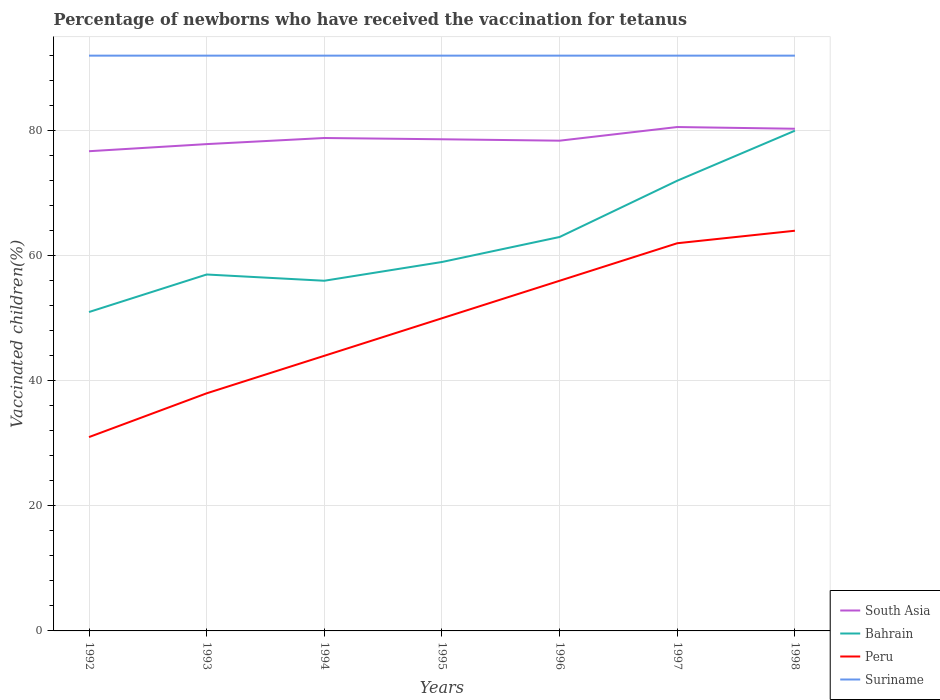Is the number of lines equal to the number of legend labels?
Offer a terse response. Yes. Across all years, what is the maximum percentage of vaccinated children in Suriname?
Provide a short and direct response. 92. In which year was the percentage of vaccinated children in Peru maximum?
Your answer should be compact. 1992. What is the difference between the highest and the second highest percentage of vaccinated children in South Asia?
Offer a terse response. 3.87. What is the difference between two consecutive major ticks on the Y-axis?
Your response must be concise. 20. Does the graph contain any zero values?
Your answer should be compact. No. Where does the legend appear in the graph?
Give a very brief answer. Bottom right. How many legend labels are there?
Ensure brevity in your answer.  4. How are the legend labels stacked?
Your response must be concise. Vertical. What is the title of the graph?
Offer a terse response. Percentage of newborns who have received the vaccination for tetanus. What is the label or title of the X-axis?
Ensure brevity in your answer.  Years. What is the label or title of the Y-axis?
Give a very brief answer. Vaccinated children(%). What is the Vaccinated children(%) of South Asia in 1992?
Provide a short and direct response. 76.72. What is the Vaccinated children(%) of Bahrain in 1992?
Make the answer very short. 51. What is the Vaccinated children(%) of Peru in 1992?
Your answer should be very brief. 31. What is the Vaccinated children(%) of Suriname in 1992?
Offer a terse response. 92. What is the Vaccinated children(%) in South Asia in 1993?
Provide a succinct answer. 77.85. What is the Vaccinated children(%) of Suriname in 1993?
Your answer should be compact. 92. What is the Vaccinated children(%) in South Asia in 1994?
Provide a short and direct response. 78.83. What is the Vaccinated children(%) of Peru in 1994?
Offer a terse response. 44. What is the Vaccinated children(%) of Suriname in 1994?
Make the answer very short. 92. What is the Vaccinated children(%) of South Asia in 1995?
Your answer should be compact. 78.63. What is the Vaccinated children(%) of Suriname in 1995?
Your answer should be very brief. 92. What is the Vaccinated children(%) in South Asia in 1996?
Ensure brevity in your answer.  78.4. What is the Vaccinated children(%) in Bahrain in 1996?
Your answer should be very brief. 63. What is the Vaccinated children(%) in Peru in 1996?
Provide a succinct answer. 56. What is the Vaccinated children(%) of Suriname in 1996?
Offer a very short reply. 92. What is the Vaccinated children(%) of South Asia in 1997?
Offer a terse response. 80.58. What is the Vaccinated children(%) of Suriname in 1997?
Make the answer very short. 92. What is the Vaccinated children(%) of South Asia in 1998?
Your answer should be compact. 80.31. What is the Vaccinated children(%) in Bahrain in 1998?
Keep it short and to the point. 80. What is the Vaccinated children(%) of Peru in 1998?
Give a very brief answer. 64. What is the Vaccinated children(%) of Suriname in 1998?
Provide a short and direct response. 92. Across all years, what is the maximum Vaccinated children(%) in South Asia?
Provide a succinct answer. 80.58. Across all years, what is the maximum Vaccinated children(%) in Suriname?
Offer a terse response. 92. Across all years, what is the minimum Vaccinated children(%) of South Asia?
Give a very brief answer. 76.72. Across all years, what is the minimum Vaccinated children(%) of Peru?
Keep it short and to the point. 31. Across all years, what is the minimum Vaccinated children(%) in Suriname?
Your response must be concise. 92. What is the total Vaccinated children(%) in South Asia in the graph?
Provide a short and direct response. 551.32. What is the total Vaccinated children(%) in Bahrain in the graph?
Ensure brevity in your answer.  438. What is the total Vaccinated children(%) of Peru in the graph?
Keep it short and to the point. 345. What is the total Vaccinated children(%) in Suriname in the graph?
Your response must be concise. 644. What is the difference between the Vaccinated children(%) of South Asia in 1992 and that in 1993?
Give a very brief answer. -1.14. What is the difference between the Vaccinated children(%) of Peru in 1992 and that in 1993?
Your answer should be compact. -7. What is the difference between the Vaccinated children(%) of South Asia in 1992 and that in 1994?
Your answer should be very brief. -2.11. What is the difference between the Vaccinated children(%) of Bahrain in 1992 and that in 1994?
Keep it short and to the point. -5. What is the difference between the Vaccinated children(%) in South Asia in 1992 and that in 1995?
Your answer should be very brief. -1.91. What is the difference between the Vaccinated children(%) in Bahrain in 1992 and that in 1995?
Make the answer very short. -8. What is the difference between the Vaccinated children(%) in Peru in 1992 and that in 1995?
Offer a terse response. -19. What is the difference between the Vaccinated children(%) of South Asia in 1992 and that in 1996?
Offer a very short reply. -1.69. What is the difference between the Vaccinated children(%) in Bahrain in 1992 and that in 1996?
Offer a terse response. -12. What is the difference between the Vaccinated children(%) in Peru in 1992 and that in 1996?
Your response must be concise. -25. What is the difference between the Vaccinated children(%) of South Asia in 1992 and that in 1997?
Keep it short and to the point. -3.87. What is the difference between the Vaccinated children(%) in Peru in 1992 and that in 1997?
Make the answer very short. -31. What is the difference between the Vaccinated children(%) of Suriname in 1992 and that in 1997?
Offer a very short reply. 0. What is the difference between the Vaccinated children(%) in South Asia in 1992 and that in 1998?
Offer a terse response. -3.59. What is the difference between the Vaccinated children(%) in Bahrain in 1992 and that in 1998?
Provide a succinct answer. -29. What is the difference between the Vaccinated children(%) in Peru in 1992 and that in 1998?
Ensure brevity in your answer.  -33. What is the difference between the Vaccinated children(%) in South Asia in 1993 and that in 1994?
Provide a short and direct response. -0.98. What is the difference between the Vaccinated children(%) in Bahrain in 1993 and that in 1994?
Offer a very short reply. 1. What is the difference between the Vaccinated children(%) in South Asia in 1993 and that in 1995?
Give a very brief answer. -0.77. What is the difference between the Vaccinated children(%) of Peru in 1993 and that in 1995?
Your response must be concise. -12. What is the difference between the Vaccinated children(%) in Suriname in 1993 and that in 1995?
Offer a terse response. 0. What is the difference between the Vaccinated children(%) of South Asia in 1993 and that in 1996?
Your response must be concise. -0.55. What is the difference between the Vaccinated children(%) of Bahrain in 1993 and that in 1996?
Make the answer very short. -6. What is the difference between the Vaccinated children(%) of South Asia in 1993 and that in 1997?
Make the answer very short. -2.73. What is the difference between the Vaccinated children(%) of Bahrain in 1993 and that in 1997?
Your answer should be compact. -15. What is the difference between the Vaccinated children(%) in Peru in 1993 and that in 1997?
Your answer should be compact. -24. What is the difference between the Vaccinated children(%) of Suriname in 1993 and that in 1997?
Give a very brief answer. 0. What is the difference between the Vaccinated children(%) in South Asia in 1993 and that in 1998?
Make the answer very short. -2.46. What is the difference between the Vaccinated children(%) in Peru in 1993 and that in 1998?
Give a very brief answer. -26. What is the difference between the Vaccinated children(%) in South Asia in 1994 and that in 1995?
Ensure brevity in your answer.  0.2. What is the difference between the Vaccinated children(%) of Peru in 1994 and that in 1995?
Provide a succinct answer. -6. What is the difference between the Vaccinated children(%) in South Asia in 1994 and that in 1996?
Your answer should be compact. 0.43. What is the difference between the Vaccinated children(%) of Bahrain in 1994 and that in 1996?
Your answer should be very brief. -7. What is the difference between the Vaccinated children(%) in Suriname in 1994 and that in 1996?
Your response must be concise. 0. What is the difference between the Vaccinated children(%) of South Asia in 1994 and that in 1997?
Offer a very short reply. -1.76. What is the difference between the Vaccinated children(%) in Suriname in 1994 and that in 1997?
Provide a short and direct response. 0. What is the difference between the Vaccinated children(%) of South Asia in 1994 and that in 1998?
Provide a short and direct response. -1.48. What is the difference between the Vaccinated children(%) in Bahrain in 1994 and that in 1998?
Provide a short and direct response. -24. What is the difference between the Vaccinated children(%) of South Asia in 1995 and that in 1996?
Your answer should be very brief. 0.22. What is the difference between the Vaccinated children(%) of Bahrain in 1995 and that in 1996?
Your answer should be compact. -4. What is the difference between the Vaccinated children(%) in Peru in 1995 and that in 1996?
Offer a terse response. -6. What is the difference between the Vaccinated children(%) in Suriname in 1995 and that in 1996?
Offer a very short reply. 0. What is the difference between the Vaccinated children(%) of South Asia in 1995 and that in 1997?
Your response must be concise. -1.96. What is the difference between the Vaccinated children(%) in Bahrain in 1995 and that in 1997?
Offer a very short reply. -13. What is the difference between the Vaccinated children(%) in South Asia in 1995 and that in 1998?
Give a very brief answer. -1.68. What is the difference between the Vaccinated children(%) of South Asia in 1996 and that in 1997?
Make the answer very short. -2.18. What is the difference between the Vaccinated children(%) of Bahrain in 1996 and that in 1997?
Give a very brief answer. -9. What is the difference between the Vaccinated children(%) of Peru in 1996 and that in 1997?
Ensure brevity in your answer.  -6. What is the difference between the Vaccinated children(%) in South Asia in 1996 and that in 1998?
Provide a succinct answer. -1.91. What is the difference between the Vaccinated children(%) of Bahrain in 1996 and that in 1998?
Provide a short and direct response. -17. What is the difference between the Vaccinated children(%) in Peru in 1996 and that in 1998?
Your response must be concise. -8. What is the difference between the Vaccinated children(%) in Suriname in 1996 and that in 1998?
Your response must be concise. 0. What is the difference between the Vaccinated children(%) of South Asia in 1997 and that in 1998?
Offer a terse response. 0.28. What is the difference between the Vaccinated children(%) of Suriname in 1997 and that in 1998?
Ensure brevity in your answer.  0. What is the difference between the Vaccinated children(%) in South Asia in 1992 and the Vaccinated children(%) in Bahrain in 1993?
Your answer should be very brief. 19.72. What is the difference between the Vaccinated children(%) of South Asia in 1992 and the Vaccinated children(%) of Peru in 1993?
Ensure brevity in your answer.  38.72. What is the difference between the Vaccinated children(%) of South Asia in 1992 and the Vaccinated children(%) of Suriname in 1993?
Your answer should be compact. -15.28. What is the difference between the Vaccinated children(%) of Bahrain in 1992 and the Vaccinated children(%) of Suriname in 1993?
Give a very brief answer. -41. What is the difference between the Vaccinated children(%) of Peru in 1992 and the Vaccinated children(%) of Suriname in 1993?
Offer a very short reply. -61. What is the difference between the Vaccinated children(%) in South Asia in 1992 and the Vaccinated children(%) in Bahrain in 1994?
Your response must be concise. 20.72. What is the difference between the Vaccinated children(%) of South Asia in 1992 and the Vaccinated children(%) of Peru in 1994?
Offer a very short reply. 32.72. What is the difference between the Vaccinated children(%) of South Asia in 1992 and the Vaccinated children(%) of Suriname in 1994?
Provide a succinct answer. -15.28. What is the difference between the Vaccinated children(%) in Bahrain in 1992 and the Vaccinated children(%) in Suriname in 1994?
Provide a succinct answer. -41. What is the difference between the Vaccinated children(%) of Peru in 1992 and the Vaccinated children(%) of Suriname in 1994?
Offer a terse response. -61. What is the difference between the Vaccinated children(%) of South Asia in 1992 and the Vaccinated children(%) of Bahrain in 1995?
Your answer should be compact. 17.72. What is the difference between the Vaccinated children(%) of South Asia in 1992 and the Vaccinated children(%) of Peru in 1995?
Give a very brief answer. 26.72. What is the difference between the Vaccinated children(%) in South Asia in 1992 and the Vaccinated children(%) in Suriname in 1995?
Your answer should be compact. -15.28. What is the difference between the Vaccinated children(%) of Bahrain in 1992 and the Vaccinated children(%) of Peru in 1995?
Ensure brevity in your answer.  1. What is the difference between the Vaccinated children(%) of Bahrain in 1992 and the Vaccinated children(%) of Suriname in 1995?
Provide a short and direct response. -41. What is the difference between the Vaccinated children(%) in Peru in 1992 and the Vaccinated children(%) in Suriname in 1995?
Provide a succinct answer. -61. What is the difference between the Vaccinated children(%) in South Asia in 1992 and the Vaccinated children(%) in Bahrain in 1996?
Your answer should be compact. 13.72. What is the difference between the Vaccinated children(%) in South Asia in 1992 and the Vaccinated children(%) in Peru in 1996?
Offer a terse response. 20.72. What is the difference between the Vaccinated children(%) of South Asia in 1992 and the Vaccinated children(%) of Suriname in 1996?
Offer a very short reply. -15.28. What is the difference between the Vaccinated children(%) of Bahrain in 1992 and the Vaccinated children(%) of Peru in 1996?
Provide a short and direct response. -5. What is the difference between the Vaccinated children(%) in Bahrain in 1992 and the Vaccinated children(%) in Suriname in 1996?
Offer a very short reply. -41. What is the difference between the Vaccinated children(%) in Peru in 1992 and the Vaccinated children(%) in Suriname in 1996?
Make the answer very short. -61. What is the difference between the Vaccinated children(%) in South Asia in 1992 and the Vaccinated children(%) in Bahrain in 1997?
Make the answer very short. 4.72. What is the difference between the Vaccinated children(%) in South Asia in 1992 and the Vaccinated children(%) in Peru in 1997?
Your answer should be compact. 14.72. What is the difference between the Vaccinated children(%) of South Asia in 1992 and the Vaccinated children(%) of Suriname in 1997?
Ensure brevity in your answer.  -15.28. What is the difference between the Vaccinated children(%) in Bahrain in 1992 and the Vaccinated children(%) in Suriname in 1997?
Your response must be concise. -41. What is the difference between the Vaccinated children(%) in Peru in 1992 and the Vaccinated children(%) in Suriname in 1997?
Ensure brevity in your answer.  -61. What is the difference between the Vaccinated children(%) of South Asia in 1992 and the Vaccinated children(%) of Bahrain in 1998?
Your response must be concise. -3.28. What is the difference between the Vaccinated children(%) in South Asia in 1992 and the Vaccinated children(%) in Peru in 1998?
Give a very brief answer. 12.72. What is the difference between the Vaccinated children(%) in South Asia in 1992 and the Vaccinated children(%) in Suriname in 1998?
Keep it short and to the point. -15.28. What is the difference between the Vaccinated children(%) of Bahrain in 1992 and the Vaccinated children(%) of Suriname in 1998?
Ensure brevity in your answer.  -41. What is the difference between the Vaccinated children(%) of Peru in 1992 and the Vaccinated children(%) of Suriname in 1998?
Ensure brevity in your answer.  -61. What is the difference between the Vaccinated children(%) of South Asia in 1993 and the Vaccinated children(%) of Bahrain in 1994?
Your response must be concise. 21.85. What is the difference between the Vaccinated children(%) of South Asia in 1993 and the Vaccinated children(%) of Peru in 1994?
Give a very brief answer. 33.85. What is the difference between the Vaccinated children(%) of South Asia in 1993 and the Vaccinated children(%) of Suriname in 1994?
Give a very brief answer. -14.15. What is the difference between the Vaccinated children(%) of Bahrain in 1993 and the Vaccinated children(%) of Peru in 1994?
Ensure brevity in your answer.  13. What is the difference between the Vaccinated children(%) in Bahrain in 1993 and the Vaccinated children(%) in Suriname in 1994?
Keep it short and to the point. -35. What is the difference between the Vaccinated children(%) in Peru in 1993 and the Vaccinated children(%) in Suriname in 1994?
Your answer should be compact. -54. What is the difference between the Vaccinated children(%) in South Asia in 1993 and the Vaccinated children(%) in Bahrain in 1995?
Offer a very short reply. 18.85. What is the difference between the Vaccinated children(%) in South Asia in 1993 and the Vaccinated children(%) in Peru in 1995?
Offer a terse response. 27.85. What is the difference between the Vaccinated children(%) of South Asia in 1993 and the Vaccinated children(%) of Suriname in 1995?
Ensure brevity in your answer.  -14.15. What is the difference between the Vaccinated children(%) of Bahrain in 1993 and the Vaccinated children(%) of Peru in 1995?
Your response must be concise. 7. What is the difference between the Vaccinated children(%) in Bahrain in 1993 and the Vaccinated children(%) in Suriname in 1995?
Your answer should be compact. -35. What is the difference between the Vaccinated children(%) in Peru in 1993 and the Vaccinated children(%) in Suriname in 1995?
Your answer should be very brief. -54. What is the difference between the Vaccinated children(%) of South Asia in 1993 and the Vaccinated children(%) of Bahrain in 1996?
Offer a terse response. 14.85. What is the difference between the Vaccinated children(%) in South Asia in 1993 and the Vaccinated children(%) in Peru in 1996?
Offer a very short reply. 21.85. What is the difference between the Vaccinated children(%) in South Asia in 1993 and the Vaccinated children(%) in Suriname in 1996?
Your answer should be compact. -14.15. What is the difference between the Vaccinated children(%) of Bahrain in 1993 and the Vaccinated children(%) of Suriname in 1996?
Ensure brevity in your answer.  -35. What is the difference between the Vaccinated children(%) in Peru in 1993 and the Vaccinated children(%) in Suriname in 1996?
Keep it short and to the point. -54. What is the difference between the Vaccinated children(%) of South Asia in 1993 and the Vaccinated children(%) of Bahrain in 1997?
Give a very brief answer. 5.85. What is the difference between the Vaccinated children(%) in South Asia in 1993 and the Vaccinated children(%) in Peru in 1997?
Offer a terse response. 15.85. What is the difference between the Vaccinated children(%) in South Asia in 1993 and the Vaccinated children(%) in Suriname in 1997?
Ensure brevity in your answer.  -14.15. What is the difference between the Vaccinated children(%) in Bahrain in 1993 and the Vaccinated children(%) in Peru in 1997?
Provide a succinct answer. -5. What is the difference between the Vaccinated children(%) in Bahrain in 1993 and the Vaccinated children(%) in Suriname in 1997?
Give a very brief answer. -35. What is the difference between the Vaccinated children(%) in Peru in 1993 and the Vaccinated children(%) in Suriname in 1997?
Offer a very short reply. -54. What is the difference between the Vaccinated children(%) in South Asia in 1993 and the Vaccinated children(%) in Bahrain in 1998?
Provide a short and direct response. -2.15. What is the difference between the Vaccinated children(%) in South Asia in 1993 and the Vaccinated children(%) in Peru in 1998?
Your answer should be compact. 13.85. What is the difference between the Vaccinated children(%) of South Asia in 1993 and the Vaccinated children(%) of Suriname in 1998?
Ensure brevity in your answer.  -14.15. What is the difference between the Vaccinated children(%) of Bahrain in 1993 and the Vaccinated children(%) of Peru in 1998?
Your answer should be compact. -7. What is the difference between the Vaccinated children(%) in Bahrain in 1993 and the Vaccinated children(%) in Suriname in 1998?
Ensure brevity in your answer.  -35. What is the difference between the Vaccinated children(%) of Peru in 1993 and the Vaccinated children(%) of Suriname in 1998?
Offer a terse response. -54. What is the difference between the Vaccinated children(%) in South Asia in 1994 and the Vaccinated children(%) in Bahrain in 1995?
Make the answer very short. 19.83. What is the difference between the Vaccinated children(%) of South Asia in 1994 and the Vaccinated children(%) of Peru in 1995?
Your response must be concise. 28.83. What is the difference between the Vaccinated children(%) in South Asia in 1994 and the Vaccinated children(%) in Suriname in 1995?
Provide a short and direct response. -13.17. What is the difference between the Vaccinated children(%) in Bahrain in 1994 and the Vaccinated children(%) in Suriname in 1995?
Your answer should be compact. -36. What is the difference between the Vaccinated children(%) in Peru in 1994 and the Vaccinated children(%) in Suriname in 1995?
Your response must be concise. -48. What is the difference between the Vaccinated children(%) of South Asia in 1994 and the Vaccinated children(%) of Bahrain in 1996?
Give a very brief answer. 15.83. What is the difference between the Vaccinated children(%) in South Asia in 1994 and the Vaccinated children(%) in Peru in 1996?
Offer a terse response. 22.83. What is the difference between the Vaccinated children(%) of South Asia in 1994 and the Vaccinated children(%) of Suriname in 1996?
Offer a very short reply. -13.17. What is the difference between the Vaccinated children(%) in Bahrain in 1994 and the Vaccinated children(%) in Suriname in 1996?
Keep it short and to the point. -36. What is the difference between the Vaccinated children(%) in Peru in 1994 and the Vaccinated children(%) in Suriname in 1996?
Provide a succinct answer. -48. What is the difference between the Vaccinated children(%) of South Asia in 1994 and the Vaccinated children(%) of Bahrain in 1997?
Offer a terse response. 6.83. What is the difference between the Vaccinated children(%) of South Asia in 1994 and the Vaccinated children(%) of Peru in 1997?
Provide a succinct answer. 16.83. What is the difference between the Vaccinated children(%) in South Asia in 1994 and the Vaccinated children(%) in Suriname in 1997?
Your answer should be compact. -13.17. What is the difference between the Vaccinated children(%) in Bahrain in 1994 and the Vaccinated children(%) in Suriname in 1997?
Give a very brief answer. -36. What is the difference between the Vaccinated children(%) of Peru in 1994 and the Vaccinated children(%) of Suriname in 1997?
Offer a terse response. -48. What is the difference between the Vaccinated children(%) of South Asia in 1994 and the Vaccinated children(%) of Bahrain in 1998?
Keep it short and to the point. -1.17. What is the difference between the Vaccinated children(%) of South Asia in 1994 and the Vaccinated children(%) of Peru in 1998?
Ensure brevity in your answer.  14.83. What is the difference between the Vaccinated children(%) of South Asia in 1994 and the Vaccinated children(%) of Suriname in 1998?
Your response must be concise. -13.17. What is the difference between the Vaccinated children(%) in Bahrain in 1994 and the Vaccinated children(%) in Suriname in 1998?
Give a very brief answer. -36. What is the difference between the Vaccinated children(%) of Peru in 1994 and the Vaccinated children(%) of Suriname in 1998?
Offer a terse response. -48. What is the difference between the Vaccinated children(%) in South Asia in 1995 and the Vaccinated children(%) in Bahrain in 1996?
Your response must be concise. 15.63. What is the difference between the Vaccinated children(%) of South Asia in 1995 and the Vaccinated children(%) of Peru in 1996?
Provide a succinct answer. 22.63. What is the difference between the Vaccinated children(%) of South Asia in 1995 and the Vaccinated children(%) of Suriname in 1996?
Provide a succinct answer. -13.37. What is the difference between the Vaccinated children(%) of Bahrain in 1995 and the Vaccinated children(%) of Suriname in 1996?
Your answer should be very brief. -33. What is the difference between the Vaccinated children(%) of Peru in 1995 and the Vaccinated children(%) of Suriname in 1996?
Offer a terse response. -42. What is the difference between the Vaccinated children(%) of South Asia in 1995 and the Vaccinated children(%) of Bahrain in 1997?
Keep it short and to the point. 6.63. What is the difference between the Vaccinated children(%) in South Asia in 1995 and the Vaccinated children(%) in Peru in 1997?
Make the answer very short. 16.63. What is the difference between the Vaccinated children(%) in South Asia in 1995 and the Vaccinated children(%) in Suriname in 1997?
Provide a succinct answer. -13.37. What is the difference between the Vaccinated children(%) in Bahrain in 1995 and the Vaccinated children(%) in Peru in 1997?
Provide a short and direct response. -3. What is the difference between the Vaccinated children(%) in Bahrain in 1995 and the Vaccinated children(%) in Suriname in 1997?
Ensure brevity in your answer.  -33. What is the difference between the Vaccinated children(%) of Peru in 1995 and the Vaccinated children(%) of Suriname in 1997?
Your answer should be compact. -42. What is the difference between the Vaccinated children(%) of South Asia in 1995 and the Vaccinated children(%) of Bahrain in 1998?
Your response must be concise. -1.37. What is the difference between the Vaccinated children(%) in South Asia in 1995 and the Vaccinated children(%) in Peru in 1998?
Make the answer very short. 14.63. What is the difference between the Vaccinated children(%) in South Asia in 1995 and the Vaccinated children(%) in Suriname in 1998?
Ensure brevity in your answer.  -13.37. What is the difference between the Vaccinated children(%) in Bahrain in 1995 and the Vaccinated children(%) in Suriname in 1998?
Give a very brief answer. -33. What is the difference between the Vaccinated children(%) of Peru in 1995 and the Vaccinated children(%) of Suriname in 1998?
Your answer should be very brief. -42. What is the difference between the Vaccinated children(%) of South Asia in 1996 and the Vaccinated children(%) of Bahrain in 1997?
Offer a terse response. 6.4. What is the difference between the Vaccinated children(%) in South Asia in 1996 and the Vaccinated children(%) in Peru in 1997?
Offer a very short reply. 16.4. What is the difference between the Vaccinated children(%) in South Asia in 1996 and the Vaccinated children(%) in Suriname in 1997?
Your answer should be compact. -13.6. What is the difference between the Vaccinated children(%) of Bahrain in 1996 and the Vaccinated children(%) of Peru in 1997?
Provide a short and direct response. 1. What is the difference between the Vaccinated children(%) of Peru in 1996 and the Vaccinated children(%) of Suriname in 1997?
Offer a very short reply. -36. What is the difference between the Vaccinated children(%) in South Asia in 1996 and the Vaccinated children(%) in Bahrain in 1998?
Your answer should be compact. -1.6. What is the difference between the Vaccinated children(%) of South Asia in 1996 and the Vaccinated children(%) of Peru in 1998?
Your answer should be compact. 14.4. What is the difference between the Vaccinated children(%) in South Asia in 1996 and the Vaccinated children(%) in Suriname in 1998?
Ensure brevity in your answer.  -13.6. What is the difference between the Vaccinated children(%) in Bahrain in 1996 and the Vaccinated children(%) in Suriname in 1998?
Make the answer very short. -29. What is the difference between the Vaccinated children(%) in Peru in 1996 and the Vaccinated children(%) in Suriname in 1998?
Your answer should be very brief. -36. What is the difference between the Vaccinated children(%) of South Asia in 1997 and the Vaccinated children(%) of Bahrain in 1998?
Ensure brevity in your answer.  0.58. What is the difference between the Vaccinated children(%) of South Asia in 1997 and the Vaccinated children(%) of Peru in 1998?
Provide a succinct answer. 16.58. What is the difference between the Vaccinated children(%) of South Asia in 1997 and the Vaccinated children(%) of Suriname in 1998?
Ensure brevity in your answer.  -11.42. What is the difference between the Vaccinated children(%) in Bahrain in 1997 and the Vaccinated children(%) in Suriname in 1998?
Make the answer very short. -20. What is the difference between the Vaccinated children(%) in Peru in 1997 and the Vaccinated children(%) in Suriname in 1998?
Ensure brevity in your answer.  -30. What is the average Vaccinated children(%) of South Asia per year?
Provide a succinct answer. 78.76. What is the average Vaccinated children(%) of Bahrain per year?
Provide a short and direct response. 62.57. What is the average Vaccinated children(%) of Peru per year?
Give a very brief answer. 49.29. What is the average Vaccinated children(%) of Suriname per year?
Make the answer very short. 92. In the year 1992, what is the difference between the Vaccinated children(%) of South Asia and Vaccinated children(%) of Bahrain?
Give a very brief answer. 25.72. In the year 1992, what is the difference between the Vaccinated children(%) in South Asia and Vaccinated children(%) in Peru?
Your answer should be very brief. 45.72. In the year 1992, what is the difference between the Vaccinated children(%) of South Asia and Vaccinated children(%) of Suriname?
Give a very brief answer. -15.28. In the year 1992, what is the difference between the Vaccinated children(%) in Bahrain and Vaccinated children(%) in Suriname?
Keep it short and to the point. -41. In the year 1992, what is the difference between the Vaccinated children(%) in Peru and Vaccinated children(%) in Suriname?
Keep it short and to the point. -61. In the year 1993, what is the difference between the Vaccinated children(%) in South Asia and Vaccinated children(%) in Bahrain?
Your answer should be very brief. 20.85. In the year 1993, what is the difference between the Vaccinated children(%) of South Asia and Vaccinated children(%) of Peru?
Provide a short and direct response. 39.85. In the year 1993, what is the difference between the Vaccinated children(%) in South Asia and Vaccinated children(%) in Suriname?
Make the answer very short. -14.15. In the year 1993, what is the difference between the Vaccinated children(%) in Bahrain and Vaccinated children(%) in Suriname?
Keep it short and to the point. -35. In the year 1993, what is the difference between the Vaccinated children(%) of Peru and Vaccinated children(%) of Suriname?
Offer a very short reply. -54. In the year 1994, what is the difference between the Vaccinated children(%) in South Asia and Vaccinated children(%) in Bahrain?
Make the answer very short. 22.83. In the year 1994, what is the difference between the Vaccinated children(%) of South Asia and Vaccinated children(%) of Peru?
Your response must be concise. 34.83. In the year 1994, what is the difference between the Vaccinated children(%) in South Asia and Vaccinated children(%) in Suriname?
Offer a terse response. -13.17. In the year 1994, what is the difference between the Vaccinated children(%) in Bahrain and Vaccinated children(%) in Suriname?
Offer a terse response. -36. In the year 1994, what is the difference between the Vaccinated children(%) in Peru and Vaccinated children(%) in Suriname?
Your response must be concise. -48. In the year 1995, what is the difference between the Vaccinated children(%) in South Asia and Vaccinated children(%) in Bahrain?
Make the answer very short. 19.63. In the year 1995, what is the difference between the Vaccinated children(%) of South Asia and Vaccinated children(%) of Peru?
Ensure brevity in your answer.  28.63. In the year 1995, what is the difference between the Vaccinated children(%) in South Asia and Vaccinated children(%) in Suriname?
Ensure brevity in your answer.  -13.37. In the year 1995, what is the difference between the Vaccinated children(%) in Bahrain and Vaccinated children(%) in Suriname?
Your answer should be very brief. -33. In the year 1995, what is the difference between the Vaccinated children(%) of Peru and Vaccinated children(%) of Suriname?
Offer a terse response. -42. In the year 1996, what is the difference between the Vaccinated children(%) of South Asia and Vaccinated children(%) of Bahrain?
Provide a succinct answer. 15.4. In the year 1996, what is the difference between the Vaccinated children(%) of South Asia and Vaccinated children(%) of Peru?
Provide a short and direct response. 22.4. In the year 1996, what is the difference between the Vaccinated children(%) of South Asia and Vaccinated children(%) of Suriname?
Offer a very short reply. -13.6. In the year 1996, what is the difference between the Vaccinated children(%) in Bahrain and Vaccinated children(%) in Peru?
Your answer should be very brief. 7. In the year 1996, what is the difference between the Vaccinated children(%) of Bahrain and Vaccinated children(%) of Suriname?
Give a very brief answer. -29. In the year 1996, what is the difference between the Vaccinated children(%) of Peru and Vaccinated children(%) of Suriname?
Your answer should be very brief. -36. In the year 1997, what is the difference between the Vaccinated children(%) in South Asia and Vaccinated children(%) in Bahrain?
Offer a very short reply. 8.58. In the year 1997, what is the difference between the Vaccinated children(%) of South Asia and Vaccinated children(%) of Peru?
Offer a very short reply. 18.58. In the year 1997, what is the difference between the Vaccinated children(%) of South Asia and Vaccinated children(%) of Suriname?
Offer a terse response. -11.42. In the year 1997, what is the difference between the Vaccinated children(%) in Peru and Vaccinated children(%) in Suriname?
Provide a short and direct response. -30. In the year 1998, what is the difference between the Vaccinated children(%) in South Asia and Vaccinated children(%) in Bahrain?
Provide a short and direct response. 0.31. In the year 1998, what is the difference between the Vaccinated children(%) in South Asia and Vaccinated children(%) in Peru?
Your answer should be compact. 16.31. In the year 1998, what is the difference between the Vaccinated children(%) in South Asia and Vaccinated children(%) in Suriname?
Your response must be concise. -11.69. In the year 1998, what is the difference between the Vaccinated children(%) of Bahrain and Vaccinated children(%) of Peru?
Your answer should be compact. 16. What is the ratio of the Vaccinated children(%) of South Asia in 1992 to that in 1993?
Offer a terse response. 0.99. What is the ratio of the Vaccinated children(%) of Bahrain in 1992 to that in 1993?
Offer a very short reply. 0.89. What is the ratio of the Vaccinated children(%) of Peru in 1992 to that in 1993?
Provide a succinct answer. 0.82. What is the ratio of the Vaccinated children(%) in Suriname in 1992 to that in 1993?
Ensure brevity in your answer.  1. What is the ratio of the Vaccinated children(%) of South Asia in 1992 to that in 1994?
Keep it short and to the point. 0.97. What is the ratio of the Vaccinated children(%) of Bahrain in 1992 to that in 1994?
Offer a terse response. 0.91. What is the ratio of the Vaccinated children(%) of Peru in 1992 to that in 1994?
Offer a terse response. 0.7. What is the ratio of the Vaccinated children(%) in Suriname in 1992 to that in 1994?
Your response must be concise. 1. What is the ratio of the Vaccinated children(%) in South Asia in 1992 to that in 1995?
Your response must be concise. 0.98. What is the ratio of the Vaccinated children(%) of Bahrain in 1992 to that in 1995?
Ensure brevity in your answer.  0.86. What is the ratio of the Vaccinated children(%) of Peru in 1992 to that in 1995?
Provide a short and direct response. 0.62. What is the ratio of the Vaccinated children(%) in Suriname in 1992 to that in 1995?
Give a very brief answer. 1. What is the ratio of the Vaccinated children(%) in South Asia in 1992 to that in 1996?
Make the answer very short. 0.98. What is the ratio of the Vaccinated children(%) in Bahrain in 1992 to that in 1996?
Keep it short and to the point. 0.81. What is the ratio of the Vaccinated children(%) of Peru in 1992 to that in 1996?
Offer a very short reply. 0.55. What is the ratio of the Vaccinated children(%) of South Asia in 1992 to that in 1997?
Provide a succinct answer. 0.95. What is the ratio of the Vaccinated children(%) in Bahrain in 1992 to that in 1997?
Provide a short and direct response. 0.71. What is the ratio of the Vaccinated children(%) of Suriname in 1992 to that in 1997?
Your answer should be compact. 1. What is the ratio of the Vaccinated children(%) of South Asia in 1992 to that in 1998?
Make the answer very short. 0.96. What is the ratio of the Vaccinated children(%) of Bahrain in 1992 to that in 1998?
Your response must be concise. 0.64. What is the ratio of the Vaccinated children(%) in Peru in 1992 to that in 1998?
Your response must be concise. 0.48. What is the ratio of the Vaccinated children(%) in Suriname in 1992 to that in 1998?
Your answer should be compact. 1. What is the ratio of the Vaccinated children(%) in South Asia in 1993 to that in 1994?
Ensure brevity in your answer.  0.99. What is the ratio of the Vaccinated children(%) in Bahrain in 1993 to that in 1994?
Your response must be concise. 1.02. What is the ratio of the Vaccinated children(%) of Peru in 1993 to that in 1994?
Ensure brevity in your answer.  0.86. What is the ratio of the Vaccinated children(%) in South Asia in 1993 to that in 1995?
Your response must be concise. 0.99. What is the ratio of the Vaccinated children(%) in Bahrain in 1993 to that in 1995?
Your answer should be very brief. 0.97. What is the ratio of the Vaccinated children(%) in Peru in 1993 to that in 1995?
Your answer should be very brief. 0.76. What is the ratio of the Vaccinated children(%) of Suriname in 1993 to that in 1995?
Your answer should be very brief. 1. What is the ratio of the Vaccinated children(%) of South Asia in 1993 to that in 1996?
Give a very brief answer. 0.99. What is the ratio of the Vaccinated children(%) of Bahrain in 1993 to that in 1996?
Provide a short and direct response. 0.9. What is the ratio of the Vaccinated children(%) in Peru in 1993 to that in 1996?
Offer a terse response. 0.68. What is the ratio of the Vaccinated children(%) in South Asia in 1993 to that in 1997?
Provide a short and direct response. 0.97. What is the ratio of the Vaccinated children(%) in Bahrain in 1993 to that in 1997?
Provide a short and direct response. 0.79. What is the ratio of the Vaccinated children(%) in Peru in 1993 to that in 1997?
Offer a terse response. 0.61. What is the ratio of the Vaccinated children(%) of South Asia in 1993 to that in 1998?
Offer a very short reply. 0.97. What is the ratio of the Vaccinated children(%) of Bahrain in 1993 to that in 1998?
Make the answer very short. 0.71. What is the ratio of the Vaccinated children(%) of Peru in 1993 to that in 1998?
Provide a short and direct response. 0.59. What is the ratio of the Vaccinated children(%) of Suriname in 1993 to that in 1998?
Ensure brevity in your answer.  1. What is the ratio of the Vaccinated children(%) of Bahrain in 1994 to that in 1995?
Provide a succinct answer. 0.95. What is the ratio of the Vaccinated children(%) in South Asia in 1994 to that in 1996?
Make the answer very short. 1.01. What is the ratio of the Vaccinated children(%) of Bahrain in 1994 to that in 1996?
Make the answer very short. 0.89. What is the ratio of the Vaccinated children(%) in Peru in 1994 to that in 1996?
Provide a succinct answer. 0.79. What is the ratio of the Vaccinated children(%) of Suriname in 1994 to that in 1996?
Offer a very short reply. 1. What is the ratio of the Vaccinated children(%) in South Asia in 1994 to that in 1997?
Keep it short and to the point. 0.98. What is the ratio of the Vaccinated children(%) in Peru in 1994 to that in 1997?
Your response must be concise. 0.71. What is the ratio of the Vaccinated children(%) in South Asia in 1994 to that in 1998?
Offer a terse response. 0.98. What is the ratio of the Vaccinated children(%) of Peru in 1994 to that in 1998?
Provide a short and direct response. 0.69. What is the ratio of the Vaccinated children(%) of Bahrain in 1995 to that in 1996?
Provide a short and direct response. 0.94. What is the ratio of the Vaccinated children(%) of Peru in 1995 to that in 1996?
Your answer should be compact. 0.89. What is the ratio of the Vaccinated children(%) in South Asia in 1995 to that in 1997?
Offer a very short reply. 0.98. What is the ratio of the Vaccinated children(%) of Bahrain in 1995 to that in 1997?
Provide a succinct answer. 0.82. What is the ratio of the Vaccinated children(%) in Peru in 1995 to that in 1997?
Give a very brief answer. 0.81. What is the ratio of the Vaccinated children(%) in Suriname in 1995 to that in 1997?
Offer a terse response. 1. What is the ratio of the Vaccinated children(%) of Bahrain in 1995 to that in 1998?
Keep it short and to the point. 0.74. What is the ratio of the Vaccinated children(%) of Peru in 1995 to that in 1998?
Offer a terse response. 0.78. What is the ratio of the Vaccinated children(%) of South Asia in 1996 to that in 1997?
Keep it short and to the point. 0.97. What is the ratio of the Vaccinated children(%) of Bahrain in 1996 to that in 1997?
Offer a terse response. 0.88. What is the ratio of the Vaccinated children(%) in Peru in 1996 to that in 1997?
Make the answer very short. 0.9. What is the ratio of the Vaccinated children(%) of Suriname in 1996 to that in 1997?
Your answer should be very brief. 1. What is the ratio of the Vaccinated children(%) of South Asia in 1996 to that in 1998?
Your answer should be very brief. 0.98. What is the ratio of the Vaccinated children(%) of Bahrain in 1996 to that in 1998?
Your response must be concise. 0.79. What is the ratio of the Vaccinated children(%) of Peru in 1996 to that in 1998?
Offer a very short reply. 0.88. What is the ratio of the Vaccinated children(%) of South Asia in 1997 to that in 1998?
Offer a very short reply. 1. What is the ratio of the Vaccinated children(%) of Peru in 1997 to that in 1998?
Offer a very short reply. 0.97. What is the ratio of the Vaccinated children(%) in Suriname in 1997 to that in 1998?
Give a very brief answer. 1. What is the difference between the highest and the second highest Vaccinated children(%) of South Asia?
Provide a short and direct response. 0.28. What is the difference between the highest and the second highest Vaccinated children(%) of Bahrain?
Your answer should be very brief. 8. What is the difference between the highest and the second highest Vaccinated children(%) in Peru?
Provide a short and direct response. 2. What is the difference between the highest and the lowest Vaccinated children(%) of South Asia?
Offer a terse response. 3.87. 